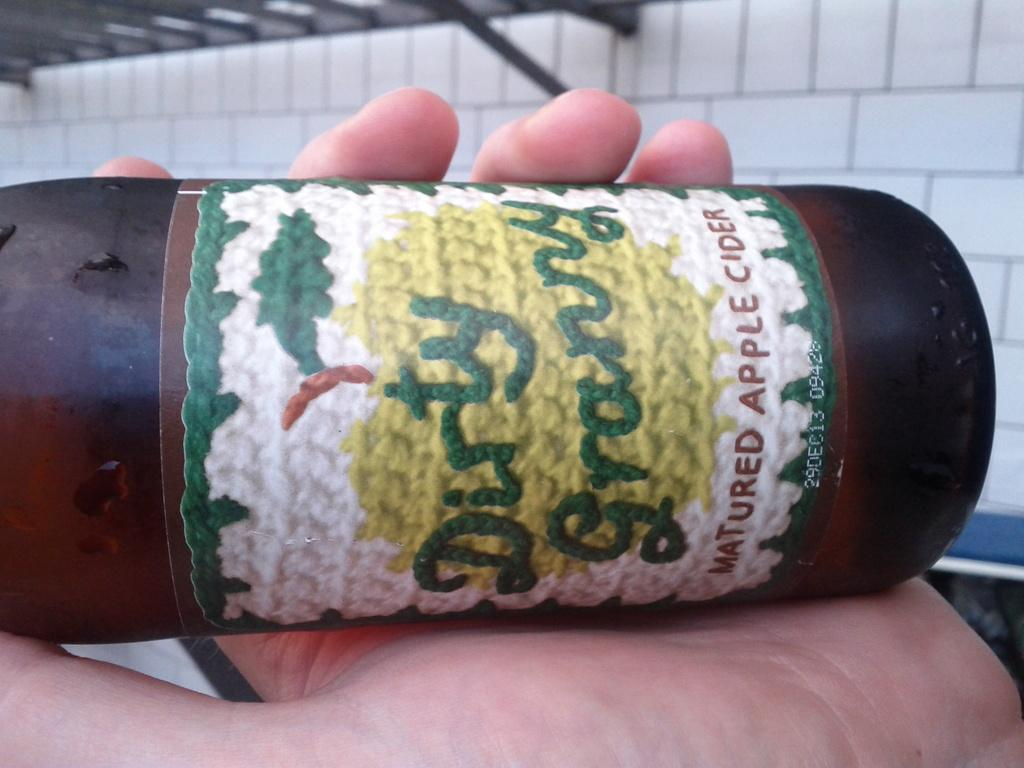Provide a one-sentence caption for the provided image. A bottle of Dirty Granny Apple cider in a persons hand. 